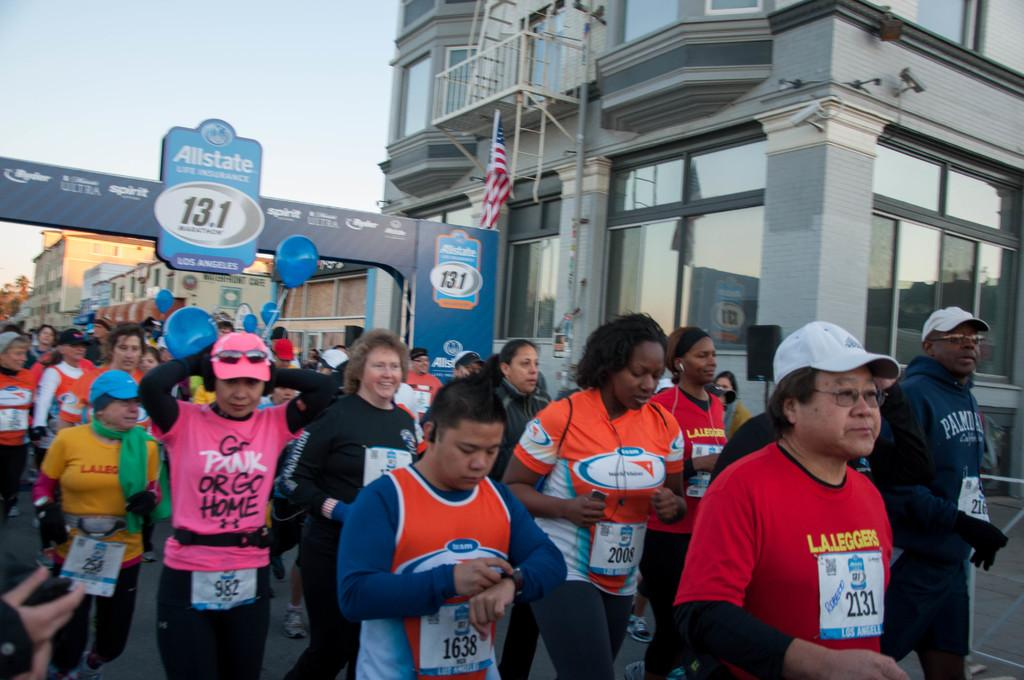What are the people in the image doing? There is a group of people running in the image. Where are the people located in the image? The group of people is at the bottom of the image. What can be seen on the left side of the image? There is a hoarding on the left side of the image. What is on the right side of the image? There is a building on the right side of the image. What is visible at the top of the image? The sky is visible at the top of the image. How many kittens are playing with a ray in the image? There are no kittens or rays present in the image. What type of team is participating in the race in the image? There is no indication of a team or race in the image; it simply shows a group of people running. 